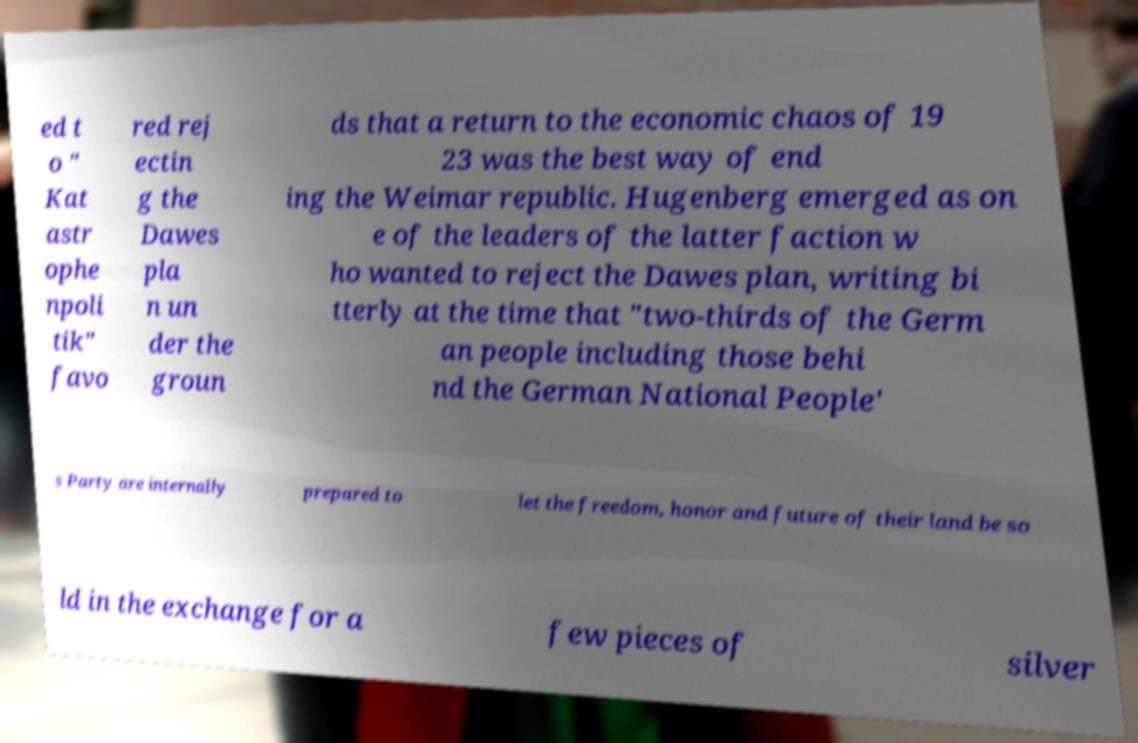Please read and relay the text visible in this image. What does it say? ed t o " Kat astr ophe npoli tik" favo red rej ectin g the Dawes pla n un der the groun ds that a return to the economic chaos of 19 23 was the best way of end ing the Weimar republic. Hugenberg emerged as on e of the leaders of the latter faction w ho wanted to reject the Dawes plan, writing bi tterly at the time that "two-thirds of the Germ an people including those behi nd the German National People' s Party are internally prepared to let the freedom, honor and future of their land be so ld in the exchange for a few pieces of silver 